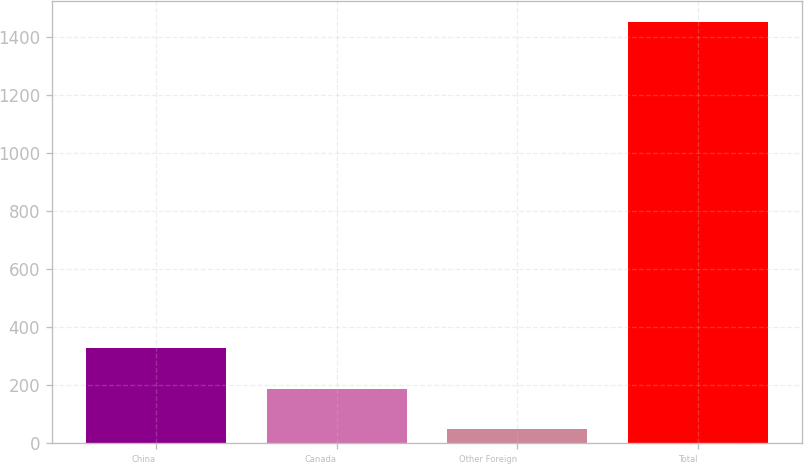Convert chart to OTSL. <chart><loc_0><loc_0><loc_500><loc_500><bar_chart><fcel>China<fcel>Canada<fcel>Other Foreign<fcel>Total<nl><fcel>328.9<fcel>188.6<fcel>48.3<fcel>1451.3<nl></chart> 